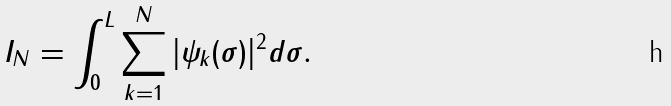<formula> <loc_0><loc_0><loc_500><loc_500>I _ { N } = \int _ { 0 } ^ { L } \sum _ { k = 1 } ^ { N } | \psi _ { k } ( \sigma ) | ^ { 2 } d \sigma .</formula> 